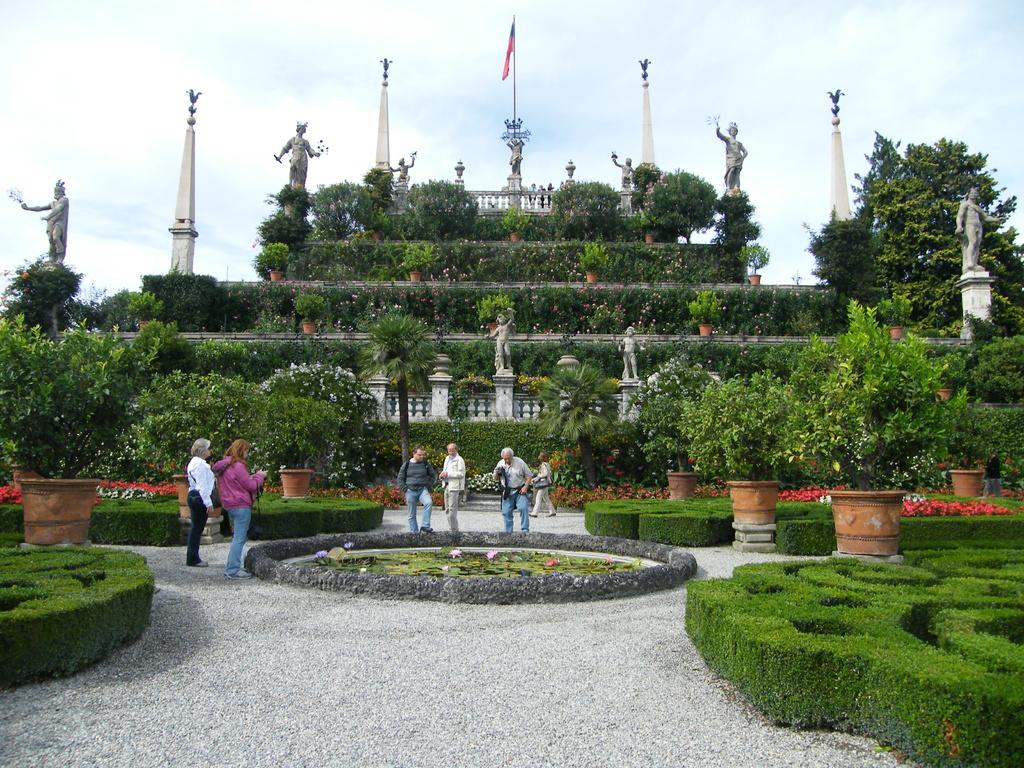What is located in the center of the image? There are plants and statues in the center of the image. What can be seen flying in the image? There is a flag in the image. What type of surface is at the bottom of the image? There are stones at the bottom of the image. What is visible at the top of the image? There is sky visible at the top of the image. Are there any people present in the image? Yes, there are people standing in the image. What type of business is being conducted in the image? There is no indication of any business activity in the image. Can you describe the weather conditions in the image? The provided facts do not mention any weather conditions, such as fog, in the image. 